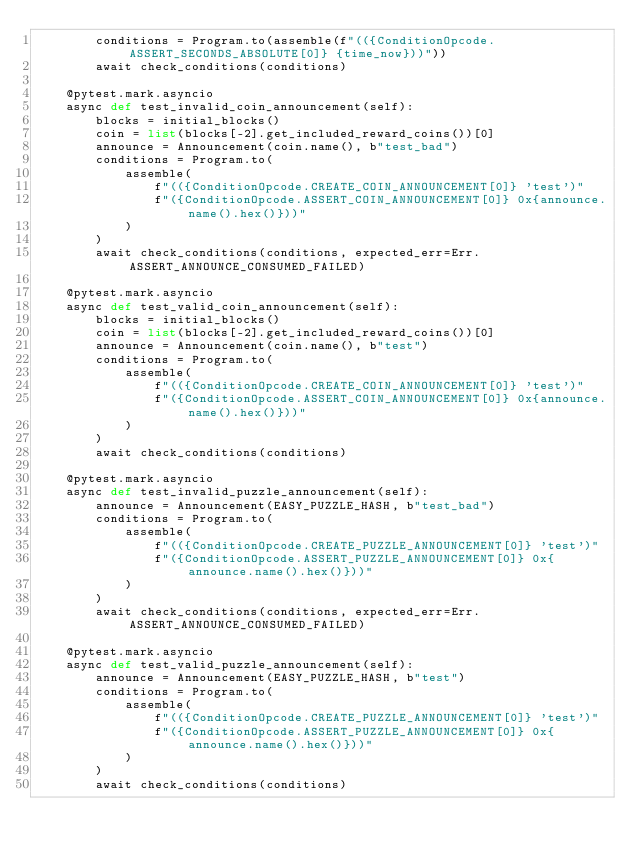<code> <loc_0><loc_0><loc_500><loc_500><_Python_>        conditions = Program.to(assemble(f"(({ConditionOpcode.ASSERT_SECONDS_ABSOLUTE[0]} {time_now}))"))
        await check_conditions(conditions)

    @pytest.mark.asyncio
    async def test_invalid_coin_announcement(self):
        blocks = initial_blocks()
        coin = list(blocks[-2].get_included_reward_coins())[0]
        announce = Announcement(coin.name(), b"test_bad")
        conditions = Program.to(
            assemble(
                f"(({ConditionOpcode.CREATE_COIN_ANNOUNCEMENT[0]} 'test')"
                f"({ConditionOpcode.ASSERT_COIN_ANNOUNCEMENT[0]} 0x{announce.name().hex()}))"
            )
        )
        await check_conditions(conditions, expected_err=Err.ASSERT_ANNOUNCE_CONSUMED_FAILED)

    @pytest.mark.asyncio
    async def test_valid_coin_announcement(self):
        blocks = initial_blocks()
        coin = list(blocks[-2].get_included_reward_coins())[0]
        announce = Announcement(coin.name(), b"test")
        conditions = Program.to(
            assemble(
                f"(({ConditionOpcode.CREATE_COIN_ANNOUNCEMENT[0]} 'test')"
                f"({ConditionOpcode.ASSERT_COIN_ANNOUNCEMENT[0]} 0x{announce.name().hex()}))"
            )
        )
        await check_conditions(conditions)

    @pytest.mark.asyncio
    async def test_invalid_puzzle_announcement(self):
        announce = Announcement(EASY_PUZZLE_HASH, b"test_bad")
        conditions = Program.to(
            assemble(
                f"(({ConditionOpcode.CREATE_PUZZLE_ANNOUNCEMENT[0]} 'test')"
                f"({ConditionOpcode.ASSERT_PUZZLE_ANNOUNCEMENT[0]} 0x{announce.name().hex()}))"
            )
        )
        await check_conditions(conditions, expected_err=Err.ASSERT_ANNOUNCE_CONSUMED_FAILED)

    @pytest.mark.asyncio
    async def test_valid_puzzle_announcement(self):
        announce = Announcement(EASY_PUZZLE_HASH, b"test")
        conditions = Program.to(
            assemble(
                f"(({ConditionOpcode.CREATE_PUZZLE_ANNOUNCEMENT[0]} 'test')"
                f"({ConditionOpcode.ASSERT_PUZZLE_ANNOUNCEMENT[0]} 0x{announce.name().hex()}))"
            )
        )
        await check_conditions(conditions)
</code> 